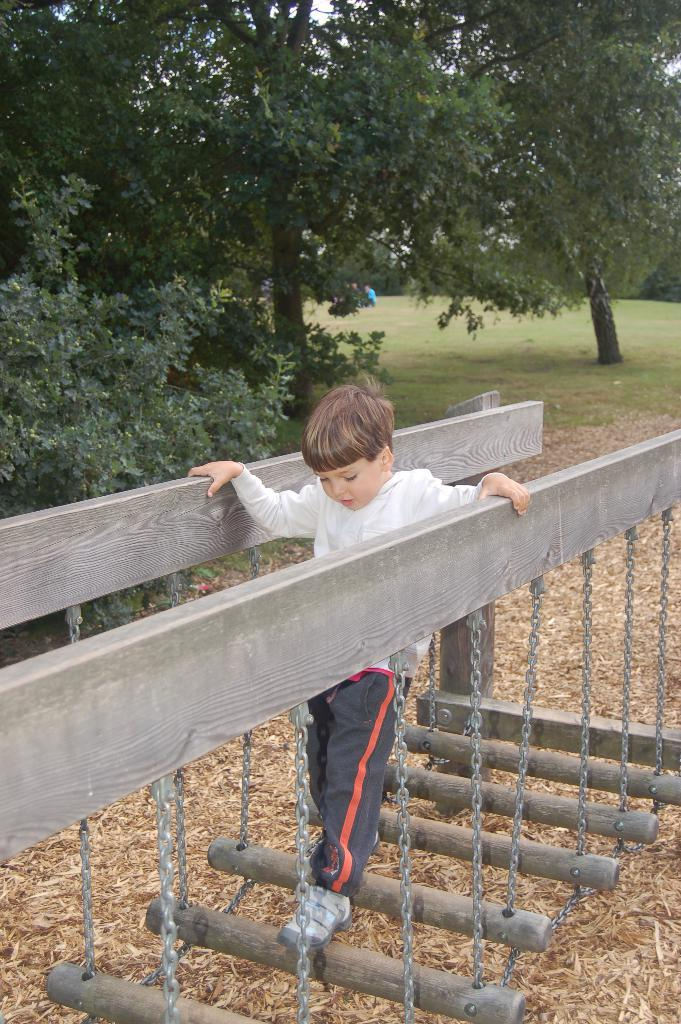Who is the main subject in the image? There is a boy in the image. What is the boy standing on? The boy is standing on a wooden way. What other objects can be seen in the image? Chains are visible in the image. What is the background of the image? There are trees behind the boy. What type of ground is visible in the image? The ground is covered with grass. What type of grain is being harvested in the image? There is no grain or harvesting activity present in the image. How many beds are visible in the image? There are no beds present in the image. 